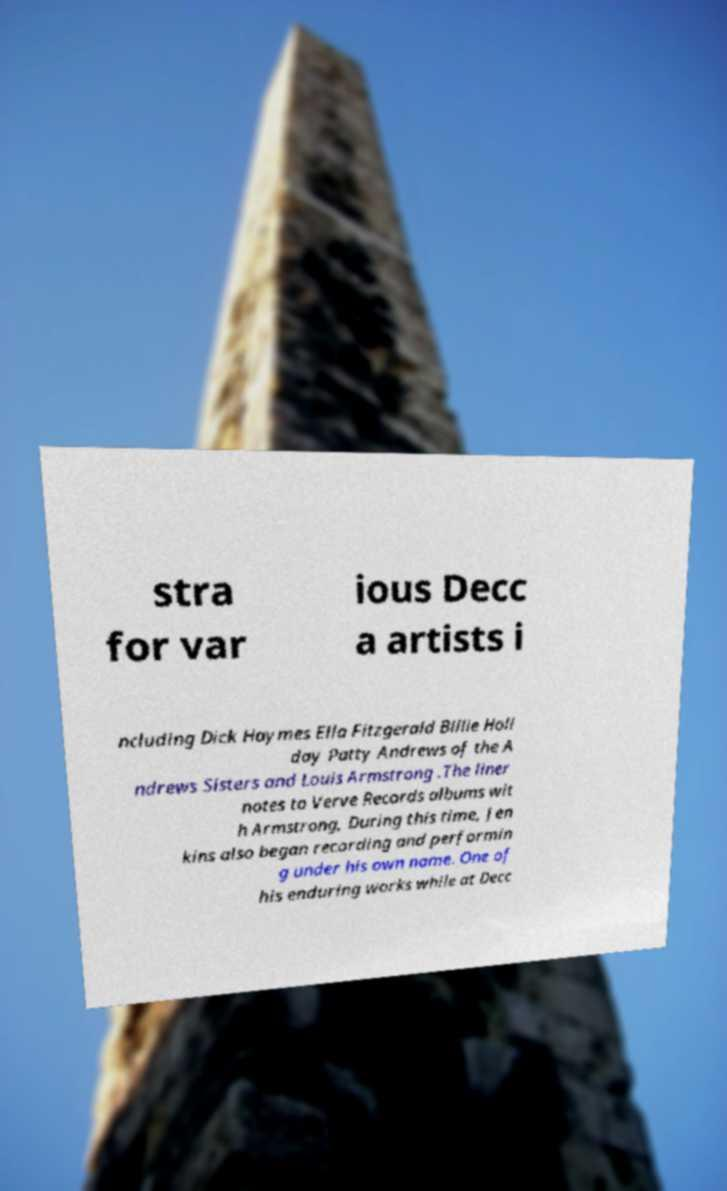Could you assist in decoding the text presented in this image and type it out clearly? stra for var ious Decc a artists i ncluding Dick Haymes Ella Fitzgerald Billie Holi day Patty Andrews of the A ndrews Sisters and Louis Armstrong .The liner notes to Verve Records albums wit h Armstrong, During this time, Jen kins also began recording and performin g under his own name. One of his enduring works while at Decc 